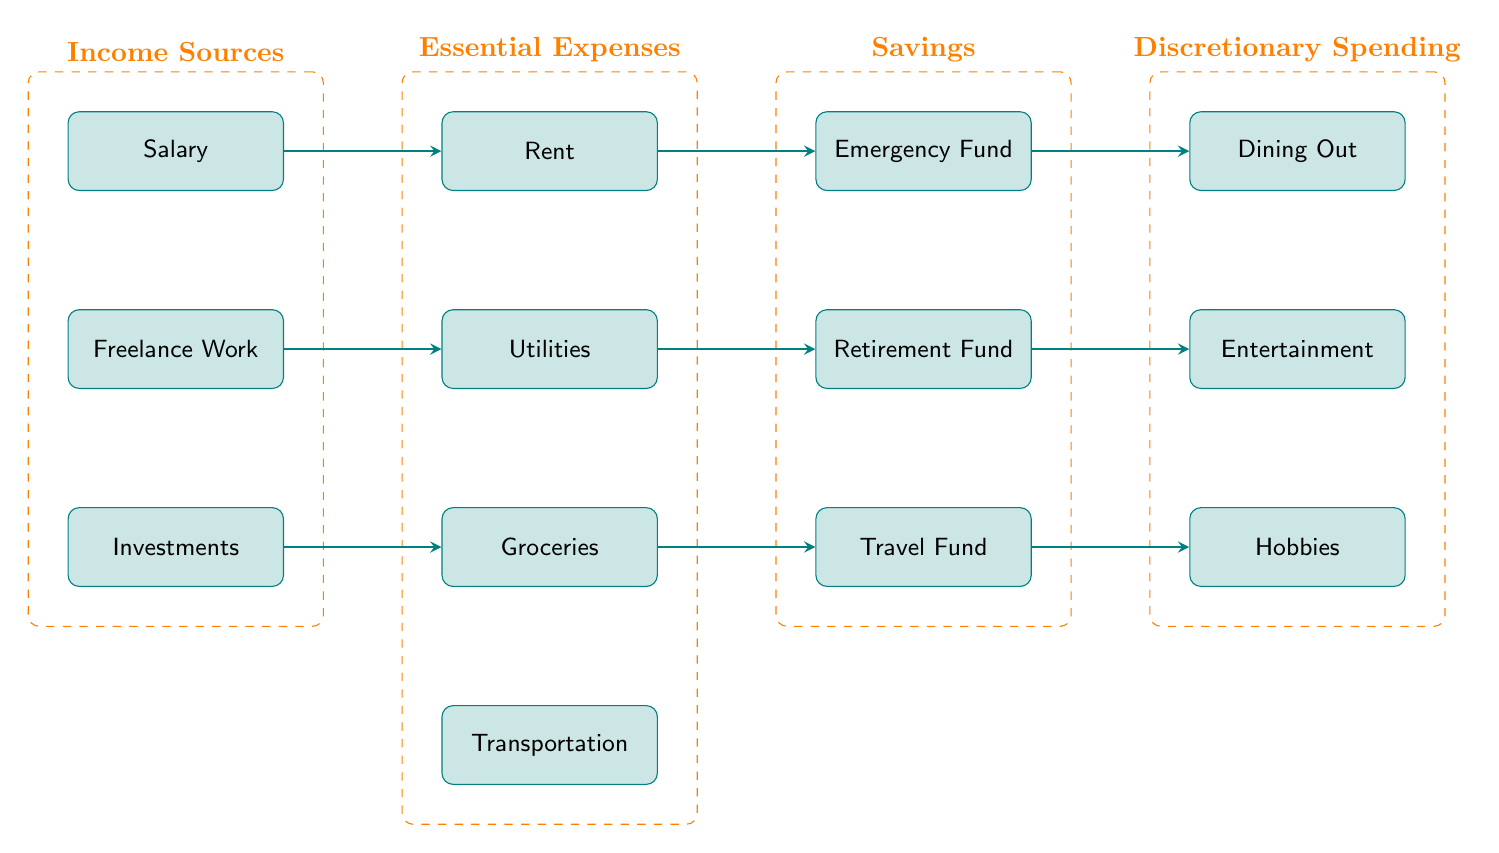What are the income sources listed in the diagram? The diagram shows three specific nodes representing income sources: Salary, Freelance Work, and Investments. These nodes are categorized under the "Income Sources" group.
Answer: Salary, Freelance Work, Investments How many essential expenses are there? By counting the nodes under the "Essential Expenses" group, we see four distinct nodes: Rent, Utilities, Groceries, and Transportation, which totals to four.
Answer: Four What happens to salary in the diagram? The arrow connects the Salary node to the Rent node, indicating that the income from salary is allocated towards essential expenses, specifically rent.
Answer: Allocated to Rent Which savings category connects to groceries? The diagram illustrates that Groceries connect to the Travel Fund node. This means that the expenses for groceries indirectly influence the funding of a travel savings category.
Answer: Travel Fund What is the last node in the discretionary spending section? In the diagram, under the "Discretionary Spending" group, the last node listed is Hobbies, positioned at the bottom of that section.
Answer: Hobbies What type of spending are utilities categorized as? Utilities are categorized under the "Essential Expenses" in the diagram, indicating they are necessary costs that must be paid regularly.
Answer: Essential Expenses If you have income from freelance work, which expense does it directly influence? The diagram shows that arrows direct from the Freelance Work node to the Utilities node, meaning income from freelance work goes toward covering utility expenses.
Answer: Utilities What connects emergency fund to dining out? The arrow extending from the Emergency Fund node to the Dining Out node indicates that funds saved for emergencies can be redirected to discretionary spending in dining out.
Answer: Dining Out 